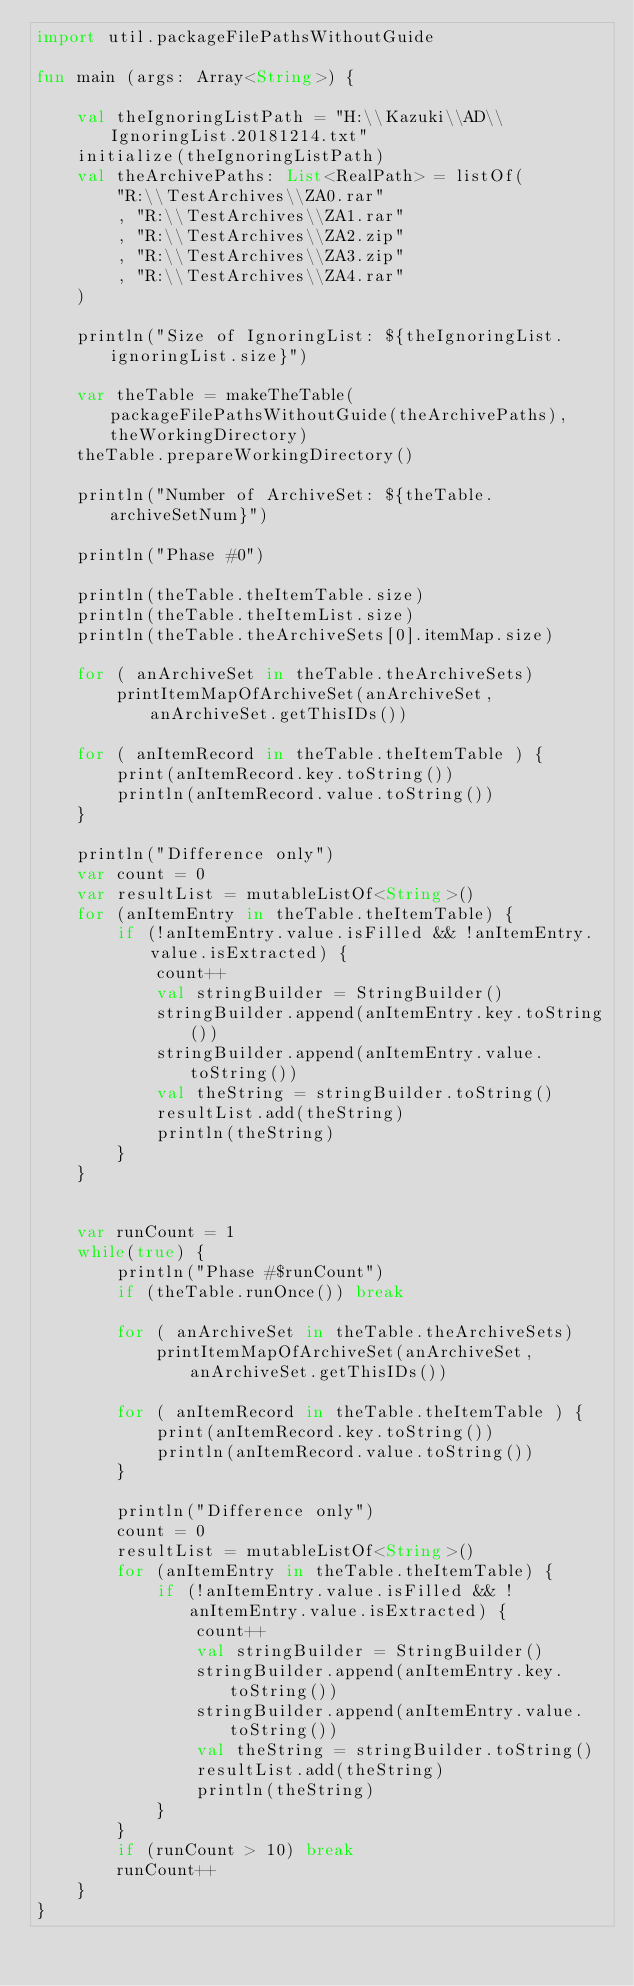Convert code to text. <code><loc_0><loc_0><loc_500><loc_500><_Kotlin_>import util.packageFilePathsWithoutGuide

fun main (args: Array<String>) {

    val theIgnoringListPath = "H:\\Kazuki\\AD\\IgnoringList.20181214.txt"
    initialize(theIgnoringListPath)
    val theArchivePaths: List<RealPath> = listOf(
        "R:\\TestArchives\\ZA0.rar"
        , "R:\\TestArchives\\ZA1.rar"
        , "R:\\TestArchives\\ZA2.zip"
        , "R:\\TestArchives\\ZA3.zip"
        , "R:\\TestArchives\\ZA4.rar"
    )

    println("Size of IgnoringList: ${theIgnoringList.ignoringList.size}")

    var theTable = makeTheTable(packageFilePathsWithoutGuide(theArchivePaths), theWorkingDirectory)
    theTable.prepareWorkingDirectory()

    println("Number of ArchiveSet: ${theTable.archiveSetNum}")

    println("Phase #0")

    println(theTable.theItemTable.size)
    println(theTable.theItemList.size)
    println(theTable.theArchiveSets[0].itemMap.size)

    for ( anArchiveSet in theTable.theArchiveSets)
        printItemMapOfArchiveSet(anArchiveSet, anArchiveSet.getThisIDs())

    for ( anItemRecord in theTable.theItemTable ) {
        print(anItemRecord.key.toString())
        println(anItemRecord.value.toString())
    }

    println("Difference only")
    var count = 0
    var resultList = mutableListOf<String>()
    for (anItemEntry in theTable.theItemTable) {
        if (!anItemEntry.value.isFilled && !anItemEntry.value.isExtracted) {
            count++
            val stringBuilder = StringBuilder()
            stringBuilder.append(anItemEntry.key.toString())
            stringBuilder.append(anItemEntry.value.toString())
            val theString = stringBuilder.toString()
            resultList.add(theString)
            println(theString)
        }
    }


    var runCount = 1
    while(true) {
        println("Phase #$runCount")
        if (theTable.runOnce()) break

        for ( anArchiveSet in theTable.theArchiveSets)
            printItemMapOfArchiveSet(anArchiveSet, anArchiveSet.getThisIDs())

        for ( anItemRecord in theTable.theItemTable ) {
            print(anItemRecord.key.toString())
            println(anItemRecord.value.toString())
        }

        println("Difference only")
        count = 0
        resultList = mutableListOf<String>()
        for (anItemEntry in theTable.theItemTable) {
            if (!anItemEntry.value.isFilled && !anItemEntry.value.isExtracted) {
                count++
                val stringBuilder = StringBuilder()
                stringBuilder.append(anItemEntry.key.toString())
                stringBuilder.append(anItemEntry.value.toString())
                val theString = stringBuilder.toString()
                resultList.add(theString)
                println(theString)
            }
        }
        if (runCount > 10) break
        runCount++
    }
}
</code> 